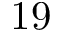<formula> <loc_0><loc_0><loc_500><loc_500>1 9</formula> 